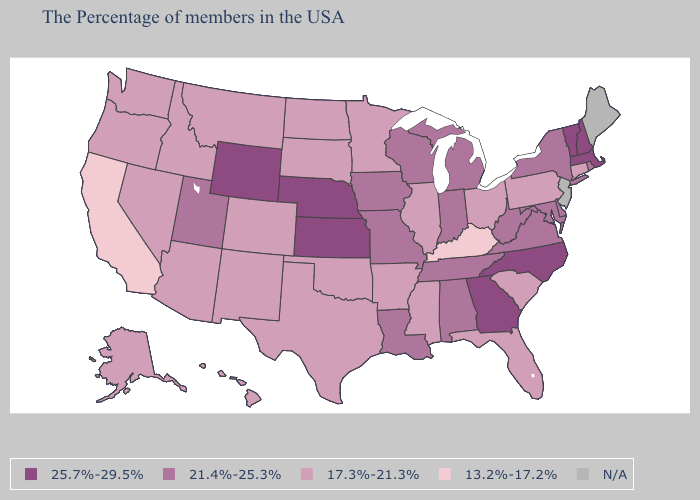Does the map have missing data?
Quick response, please. Yes. What is the highest value in the USA?
Concise answer only. 25.7%-29.5%. Does Arkansas have the lowest value in the USA?
Concise answer only. No. Which states hav the highest value in the West?
Concise answer only. Wyoming. What is the value of Georgia?
Keep it brief. 25.7%-29.5%. Does Kansas have the highest value in the USA?
Write a very short answer. Yes. Is the legend a continuous bar?
Give a very brief answer. No. Which states hav the highest value in the South?
Be succinct. North Carolina, Georgia. Among the states that border Texas , does Arkansas have the highest value?
Answer briefly. No. What is the lowest value in the West?
Give a very brief answer. 13.2%-17.2%. Name the states that have a value in the range 13.2%-17.2%?
Write a very short answer. Kentucky, California. What is the value of Minnesota?
Answer briefly. 17.3%-21.3%. What is the value of Oklahoma?
Write a very short answer. 17.3%-21.3%. 